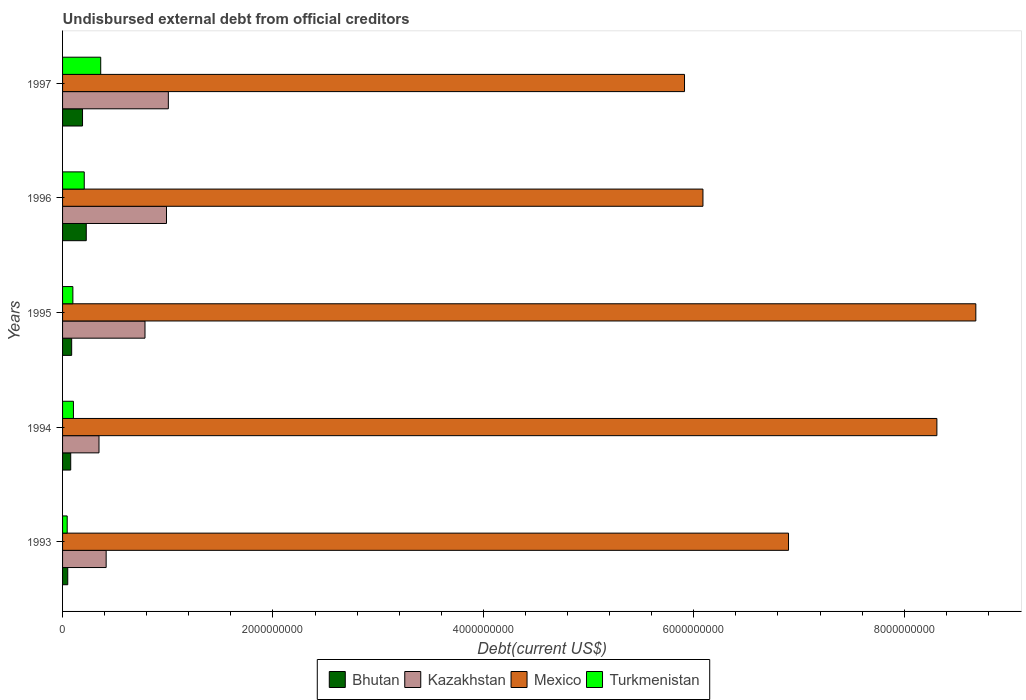Are the number of bars per tick equal to the number of legend labels?
Your response must be concise. Yes. Are the number of bars on each tick of the Y-axis equal?
Your response must be concise. Yes. How many bars are there on the 3rd tick from the top?
Make the answer very short. 4. How many bars are there on the 5th tick from the bottom?
Provide a short and direct response. 4. In how many cases, is the number of bars for a given year not equal to the number of legend labels?
Offer a very short reply. 0. What is the total debt in Bhutan in 1997?
Make the answer very short. 1.90e+08. Across all years, what is the maximum total debt in Mexico?
Offer a very short reply. 8.68e+09. Across all years, what is the minimum total debt in Bhutan?
Your answer should be compact. 4.93e+07. In which year was the total debt in Mexico maximum?
Your answer should be very brief. 1995. What is the total total debt in Kazakhstan in the graph?
Make the answer very short. 3.54e+09. What is the difference between the total debt in Mexico in 1994 and that in 1997?
Your answer should be very brief. 2.40e+09. What is the difference between the total debt in Kazakhstan in 1994 and the total debt in Turkmenistan in 1996?
Your answer should be very brief. 1.40e+08. What is the average total debt in Bhutan per year?
Give a very brief answer. 1.26e+08. In the year 1996, what is the difference between the total debt in Bhutan and total debt in Mexico?
Your response must be concise. -5.86e+09. What is the ratio of the total debt in Turkmenistan in 1993 to that in 1995?
Your response must be concise. 0.45. What is the difference between the highest and the second highest total debt in Turkmenistan?
Your answer should be very brief. 1.57e+08. What is the difference between the highest and the lowest total debt in Mexico?
Keep it short and to the point. 2.77e+09. In how many years, is the total debt in Bhutan greater than the average total debt in Bhutan taken over all years?
Provide a succinct answer. 2. Is the sum of the total debt in Bhutan in 1995 and 1997 greater than the maximum total debt in Mexico across all years?
Ensure brevity in your answer.  No. Is it the case that in every year, the sum of the total debt in Mexico and total debt in Kazakhstan is greater than the sum of total debt in Turkmenistan and total debt in Bhutan?
Provide a short and direct response. No. What does the 1st bar from the bottom in 1993 represents?
Keep it short and to the point. Bhutan. Is it the case that in every year, the sum of the total debt in Mexico and total debt in Bhutan is greater than the total debt in Kazakhstan?
Provide a succinct answer. Yes. How many bars are there?
Offer a very short reply. 20. Are all the bars in the graph horizontal?
Make the answer very short. Yes. How many years are there in the graph?
Offer a terse response. 5. What is the difference between two consecutive major ticks on the X-axis?
Make the answer very short. 2.00e+09. Does the graph contain grids?
Make the answer very short. No. Where does the legend appear in the graph?
Provide a succinct answer. Bottom center. How many legend labels are there?
Provide a short and direct response. 4. How are the legend labels stacked?
Your answer should be very brief. Horizontal. What is the title of the graph?
Ensure brevity in your answer.  Undisbursed external debt from official creditors. Does "Somalia" appear as one of the legend labels in the graph?
Offer a very short reply. No. What is the label or title of the X-axis?
Keep it short and to the point. Debt(current US$). What is the Debt(current US$) in Bhutan in 1993?
Keep it short and to the point. 4.93e+07. What is the Debt(current US$) of Kazakhstan in 1993?
Provide a succinct answer. 4.14e+08. What is the Debt(current US$) of Mexico in 1993?
Offer a very short reply. 6.90e+09. What is the Debt(current US$) in Turkmenistan in 1993?
Keep it short and to the point. 4.41e+07. What is the Debt(current US$) of Bhutan in 1994?
Offer a very short reply. 7.74e+07. What is the Debt(current US$) of Kazakhstan in 1994?
Your answer should be very brief. 3.46e+08. What is the Debt(current US$) in Mexico in 1994?
Offer a very short reply. 8.31e+09. What is the Debt(current US$) of Turkmenistan in 1994?
Give a very brief answer. 1.03e+08. What is the Debt(current US$) in Bhutan in 1995?
Your response must be concise. 8.66e+07. What is the Debt(current US$) in Kazakhstan in 1995?
Your answer should be very brief. 7.84e+08. What is the Debt(current US$) of Mexico in 1995?
Provide a succinct answer. 8.68e+09. What is the Debt(current US$) of Turkmenistan in 1995?
Offer a very short reply. 9.80e+07. What is the Debt(current US$) of Bhutan in 1996?
Give a very brief answer. 2.25e+08. What is the Debt(current US$) of Kazakhstan in 1996?
Ensure brevity in your answer.  9.88e+08. What is the Debt(current US$) in Mexico in 1996?
Ensure brevity in your answer.  6.09e+09. What is the Debt(current US$) in Turkmenistan in 1996?
Make the answer very short. 2.06e+08. What is the Debt(current US$) in Bhutan in 1997?
Provide a short and direct response. 1.90e+08. What is the Debt(current US$) of Kazakhstan in 1997?
Give a very brief answer. 1.01e+09. What is the Debt(current US$) in Mexico in 1997?
Provide a succinct answer. 5.91e+09. What is the Debt(current US$) of Turkmenistan in 1997?
Offer a terse response. 3.63e+08. Across all years, what is the maximum Debt(current US$) of Bhutan?
Your response must be concise. 2.25e+08. Across all years, what is the maximum Debt(current US$) of Kazakhstan?
Offer a terse response. 1.01e+09. Across all years, what is the maximum Debt(current US$) in Mexico?
Give a very brief answer. 8.68e+09. Across all years, what is the maximum Debt(current US$) of Turkmenistan?
Offer a terse response. 3.63e+08. Across all years, what is the minimum Debt(current US$) in Bhutan?
Provide a succinct answer. 4.93e+07. Across all years, what is the minimum Debt(current US$) of Kazakhstan?
Keep it short and to the point. 3.46e+08. Across all years, what is the minimum Debt(current US$) in Mexico?
Your response must be concise. 5.91e+09. Across all years, what is the minimum Debt(current US$) in Turkmenistan?
Offer a very short reply. 4.41e+07. What is the total Debt(current US$) in Bhutan in the graph?
Your answer should be very brief. 6.28e+08. What is the total Debt(current US$) in Kazakhstan in the graph?
Ensure brevity in your answer.  3.54e+09. What is the total Debt(current US$) of Mexico in the graph?
Your answer should be very brief. 3.59e+1. What is the total Debt(current US$) of Turkmenistan in the graph?
Provide a succinct answer. 8.14e+08. What is the difference between the Debt(current US$) of Bhutan in 1993 and that in 1994?
Your response must be concise. -2.82e+07. What is the difference between the Debt(current US$) in Kazakhstan in 1993 and that in 1994?
Provide a succinct answer. 6.80e+07. What is the difference between the Debt(current US$) in Mexico in 1993 and that in 1994?
Make the answer very short. -1.41e+09. What is the difference between the Debt(current US$) of Turkmenistan in 1993 and that in 1994?
Make the answer very short. -5.92e+07. What is the difference between the Debt(current US$) of Bhutan in 1993 and that in 1995?
Offer a very short reply. -3.73e+07. What is the difference between the Debt(current US$) in Kazakhstan in 1993 and that in 1995?
Give a very brief answer. -3.69e+08. What is the difference between the Debt(current US$) in Mexico in 1993 and that in 1995?
Provide a short and direct response. -1.78e+09. What is the difference between the Debt(current US$) in Turkmenistan in 1993 and that in 1995?
Your answer should be very brief. -5.39e+07. What is the difference between the Debt(current US$) in Bhutan in 1993 and that in 1996?
Offer a terse response. -1.76e+08. What is the difference between the Debt(current US$) of Kazakhstan in 1993 and that in 1996?
Provide a succinct answer. -5.74e+08. What is the difference between the Debt(current US$) in Mexico in 1993 and that in 1996?
Your answer should be compact. 8.13e+08. What is the difference between the Debt(current US$) in Turkmenistan in 1993 and that in 1996?
Your response must be concise. -1.62e+08. What is the difference between the Debt(current US$) in Bhutan in 1993 and that in 1997?
Make the answer very short. -1.40e+08. What is the difference between the Debt(current US$) in Kazakhstan in 1993 and that in 1997?
Your response must be concise. -5.91e+08. What is the difference between the Debt(current US$) in Mexico in 1993 and that in 1997?
Offer a very short reply. 9.88e+08. What is the difference between the Debt(current US$) in Turkmenistan in 1993 and that in 1997?
Keep it short and to the point. -3.18e+08. What is the difference between the Debt(current US$) of Bhutan in 1994 and that in 1995?
Keep it short and to the point. -9.17e+06. What is the difference between the Debt(current US$) of Kazakhstan in 1994 and that in 1995?
Give a very brief answer. -4.37e+08. What is the difference between the Debt(current US$) in Mexico in 1994 and that in 1995?
Ensure brevity in your answer.  -3.70e+08. What is the difference between the Debt(current US$) of Turkmenistan in 1994 and that in 1995?
Provide a succinct answer. 5.30e+06. What is the difference between the Debt(current US$) in Bhutan in 1994 and that in 1996?
Your answer should be very brief. -1.48e+08. What is the difference between the Debt(current US$) in Kazakhstan in 1994 and that in 1996?
Ensure brevity in your answer.  -6.42e+08. What is the difference between the Debt(current US$) of Mexico in 1994 and that in 1996?
Give a very brief answer. 2.22e+09. What is the difference between the Debt(current US$) of Turkmenistan in 1994 and that in 1996?
Offer a terse response. -1.03e+08. What is the difference between the Debt(current US$) of Bhutan in 1994 and that in 1997?
Your answer should be very brief. -1.12e+08. What is the difference between the Debt(current US$) of Kazakhstan in 1994 and that in 1997?
Offer a very short reply. -6.59e+08. What is the difference between the Debt(current US$) of Mexico in 1994 and that in 1997?
Your response must be concise. 2.40e+09. What is the difference between the Debt(current US$) of Turkmenistan in 1994 and that in 1997?
Offer a terse response. -2.59e+08. What is the difference between the Debt(current US$) in Bhutan in 1995 and that in 1996?
Provide a short and direct response. -1.39e+08. What is the difference between the Debt(current US$) of Kazakhstan in 1995 and that in 1996?
Provide a short and direct response. -2.04e+08. What is the difference between the Debt(current US$) in Mexico in 1995 and that in 1996?
Your response must be concise. 2.59e+09. What is the difference between the Debt(current US$) of Turkmenistan in 1995 and that in 1996?
Make the answer very short. -1.08e+08. What is the difference between the Debt(current US$) of Bhutan in 1995 and that in 1997?
Your response must be concise. -1.03e+08. What is the difference between the Debt(current US$) in Kazakhstan in 1995 and that in 1997?
Offer a terse response. -2.22e+08. What is the difference between the Debt(current US$) of Mexico in 1995 and that in 1997?
Provide a succinct answer. 2.77e+09. What is the difference between the Debt(current US$) in Turkmenistan in 1995 and that in 1997?
Your response must be concise. -2.65e+08. What is the difference between the Debt(current US$) in Bhutan in 1996 and that in 1997?
Provide a succinct answer. 3.55e+07. What is the difference between the Debt(current US$) in Kazakhstan in 1996 and that in 1997?
Your response must be concise. -1.75e+07. What is the difference between the Debt(current US$) of Mexico in 1996 and that in 1997?
Offer a very short reply. 1.75e+08. What is the difference between the Debt(current US$) in Turkmenistan in 1996 and that in 1997?
Your answer should be very brief. -1.57e+08. What is the difference between the Debt(current US$) in Bhutan in 1993 and the Debt(current US$) in Kazakhstan in 1994?
Your response must be concise. -2.97e+08. What is the difference between the Debt(current US$) of Bhutan in 1993 and the Debt(current US$) of Mexico in 1994?
Make the answer very short. -8.26e+09. What is the difference between the Debt(current US$) in Bhutan in 1993 and the Debt(current US$) in Turkmenistan in 1994?
Give a very brief answer. -5.40e+07. What is the difference between the Debt(current US$) of Kazakhstan in 1993 and the Debt(current US$) of Mexico in 1994?
Make the answer very short. -7.90e+09. What is the difference between the Debt(current US$) of Kazakhstan in 1993 and the Debt(current US$) of Turkmenistan in 1994?
Keep it short and to the point. 3.11e+08. What is the difference between the Debt(current US$) of Mexico in 1993 and the Debt(current US$) of Turkmenistan in 1994?
Your answer should be very brief. 6.80e+09. What is the difference between the Debt(current US$) of Bhutan in 1993 and the Debt(current US$) of Kazakhstan in 1995?
Make the answer very short. -7.34e+08. What is the difference between the Debt(current US$) of Bhutan in 1993 and the Debt(current US$) of Mexico in 1995?
Make the answer very short. -8.63e+09. What is the difference between the Debt(current US$) in Bhutan in 1993 and the Debt(current US$) in Turkmenistan in 1995?
Make the answer very short. -4.87e+07. What is the difference between the Debt(current US$) in Kazakhstan in 1993 and the Debt(current US$) in Mexico in 1995?
Make the answer very short. -8.27e+09. What is the difference between the Debt(current US$) in Kazakhstan in 1993 and the Debt(current US$) in Turkmenistan in 1995?
Provide a short and direct response. 3.16e+08. What is the difference between the Debt(current US$) of Mexico in 1993 and the Debt(current US$) of Turkmenistan in 1995?
Offer a very short reply. 6.80e+09. What is the difference between the Debt(current US$) in Bhutan in 1993 and the Debt(current US$) in Kazakhstan in 1996?
Provide a short and direct response. -9.39e+08. What is the difference between the Debt(current US$) of Bhutan in 1993 and the Debt(current US$) of Mexico in 1996?
Ensure brevity in your answer.  -6.04e+09. What is the difference between the Debt(current US$) of Bhutan in 1993 and the Debt(current US$) of Turkmenistan in 1996?
Your answer should be very brief. -1.57e+08. What is the difference between the Debt(current US$) of Kazakhstan in 1993 and the Debt(current US$) of Mexico in 1996?
Offer a very short reply. -5.67e+09. What is the difference between the Debt(current US$) in Kazakhstan in 1993 and the Debt(current US$) in Turkmenistan in 1996?
Keep it short and to the point. 2.08e+08. What is the difference between the Debt(current US$) of Mexico in 1993 and the Debt(current US$) of Turkmenistan in 1996?
Provide a short and direct response. 6.69e+09. What is the difference between the Debt(current US$) in Bhutan in 1993 and the Debt(current US$) in Kazakhstan in 1997?
Your answer should be very brief. -9.56e+08. What is the difference between the Debt(current US$) of Bhutan in 1993 and the Debt(current US$) of Mexico in 1997?
Your response must be concise. -5.86e+09. What is the difference between the Debt(current US$) of Bhutan in 1993 and the Debt(current US$) of Turkmenistan in 1997?
Provide a succinct answer. -3.13e+08. What is the difference between the Debt(current US$) in Kazakhstan in 1993 and the Debt(current US$) in Mexico in 1997?
Provide a succinct answer. -5.50e+09. What is the difference between the Debt(current US$) of Kazakhstan in 1993 and the Debt(current US$) of Turkmenistan in 1997?
Your response must be concise. 5.17e+07. What is the difference between the Debt(current US$) in Mexico in 1993 and the Debt(current US$) in Turkmenistan in 1997?
Ensure brevity in your answer.  6.54e+09. What is the difference between the Debt(current US$) of Bhutan in 1994 and the Debt(current US$) of Kazakhstan in 1995?
Your response must be concise. -7.06e+08. What is the difference between the Debt(current US$) of Bhutan in 1994 and the Debt(current US$) of Mexico in 1995?
Offer a terse response. -8.60e+09. What is the difference between the Debt(current US$) in Bhutan in 1994 and the Debt(current US$) in Turkmenistan in 1995?
Your answer should be compact. -2.06e+07. What is the difference between the Debt(current US$) in Kazakhstan in 1994 and the Debt(current US$) in Mexico in 1995?
Make the answer very short. -8.33e+09. What is the difference between the Debt(current US$) of Kazakhstan in 1994 and the Debt(current US$) of Turkmenistan in 1995?
Your response must be concise. 2.48e+08. What is the difference between the Debt(current US$) of Mexico in 1994 and the Debt(current US$) of Turkmenistan in 1995?
Provide a succinct answer. 8.21e+09. What is the difference between the Debt(current US$) in Bhutan in 1994 and the Debt(current US$) in Kazakhstan in 1996?
Your answer should be compact. -9.10e+08. What is the difference between the Debt(current US$) in Bhutan in 1994 and the Debt(current US$) in Mexico in 1996?
Give a very brief answer. -6.01e+09. What is the difference between the Debt(current US$) of Bhutan in 1994 and the Debt(current US$) of Turkmenistan in 1996?
Ensure brevity in your answer.  -1.29e+08. What is the difference between the Debt(current US$) in Kazakhstan in 1994 and the Debt(current US$) in Mexico in 1996?
Your answer should be compact. -5.74e+09. What is the difference between the Debt(current US$) of Kazakhstan in 1994 and the Debt(current US$) of Turkmenistan in 1996?
Your answer should be compact. 1.40e+08. What is the difference between the Debt(current US$) of Mexico in 1994 and the Debt(current US$) of Turkmenistan in 1996?
Provide a succinct answer. 8.10e+09. What is the difference between the Debt(current US$) in Bhutan in 1994 and the Debt(current US$) in Kazakhstan in 1997?
Give a very brief answer. -9.28e+08. What is the difference between the Debt(current US$) of Bhutan in 1994 and the Debt(current US$) of Mexico in 1997?
Provide a succinct answer. -5.83e+09. What is the difference between the Debt(current US$) in Bhutan in 1994 and the Debt(current US$) in Turkmenistan in 1997?
Your answer should be compact. -2.85e+08. What is the difference between the Debt(current US$) in Kazakhstan in 1994 and the Debt(current US$) in Mexico in 1997?
Make the answer very short. -5.57e+09. What is the difference between the Debt(current US$) in Kazakhstan in 1994 and the Debt(current US$) in Turkmenistan in 1997?
Provide a short and direct response. -1.63e+07. What is the difference between the Debt(current US$) in Mexico in 1994 and the Debt(current US$) in Turkmenistan in 1997?
Your answer should be very brief. 7.95e+09. What is the difference between the Debt(current US$) of Bhutan in 1995 and the Debt(current US$) of Kazakhstan in 1996?
Provide a short and direct response. -9.01e+08. What is the difference between the Debt(current US$) of Bhutan in 1995 and the Debt(current US$) of Mexico in 1996?
Your response must be concise. -6.00e+09. What is the difference between the Debt(current US$) of Bhutan in 1995 and the Debt(current US$) of Turkmenistan in 1996?
Your answer should be compact. -1.19e+08. What is the difference between the Debt(current US$) in Kazakhstan in 1995 and the Debt(current US$) in Mexico in 1996?
Your response must be concise. -5.30e+09. What is the difference between the Debt(current US$) of Kazakhstan in 1995 and the Debt(current US$) of Turkmenistan in 1996?
Your response must be concise. 5.78e+08. What is the difference between the Debt(current US$) in Mexico in 1995 and the Debt(current US$) in Turkmenistan in 1996?
Provide a short and direct response. 8.47e+09. What is the difference between the Debt(current US$) in Bhutan in 1995 and the Debt(current US$) in Kazakhstan in 1997?
Your answer should be very brief. -9.19e+08. What is the difference between the Debt(current US$) of Bhutan in 1995 and the Debt(current US$) of Mexico in 1997?
Your answer should be very brief. -5.83e+09. What is the difference between the Debt(current US$) of Bhutan in 1995 and the Debt(current US$) of Turkmenistan in 1997?
Give a very brief answer. -2.76e+08. What is the difference between the Debt(current US$) in Kazakhstan in 1995 and the Debt(current US$) in Mexico in 1997?
Offer a very short reply. -5.13e+09. What is the difference between the Debt(current US$) in Kazakhstan in 1995 and the Debt(current US$) in Turkmenistan in 1997?
Provide a succinct answer. 4.21e+08. What is the difference between the Debt(current US$) of Mexico in 1995 and the Debt(current US$) of Turkmenistan in 1997?
Offer a very short reply. 8.32e+09. What is the difference between the Debt(current US$) in Bhutan in 1996 and the Debt(current US$) in Kazakhstan in 1997?
Provide a succinct answer. -7.80e+08. What is the difference between the Debt(current US$) in Bhutan in 1996 and the Debt(current US$) in Mexico in 1997?
Your answer should be compact. -5.69e+09. What is the difference between the Debt(current US$) of Bhutan in 1996 and the Debt(current US$) of Turkmenistan in 1997?
Provide a succinct answer. -1.37e+08. What is the difference between the Debt(current US$) in Kazakhstan in 1996 and the Debt(current US$) in Mexico in 1997?
Keep it short and to the point. -4.92e+09. What is the difference between the Debt(current US$) in Kazakhstan in 1996 and the Debt(current US$) in Turkmenistan in 1997?
Offer a very short reply. 6.25e+08. What is the difference between the Debt(current US$) of Mexico in 1996 and the Debt(current US$) of Turkmenistan in 1997?
Your answer should be compact. 5.72e+09. What is the average Debt(current US$) of Bhutan per year?
Make the answer very short. 1.26e+08. What is the average Debt(current US$) in Kazakhstan per year?
Provide a succinct answer. 7.08e+08. What is the average Debt(current US$) in Mexico per year?
Provide a short and direct response. 7.18e+09. What is the average Debt(current US$) in Turkmenistan per year?
Your response must be concise. 1.63e+08. In the year 1993, what is the difference between the Debt(current US$) of Bhutan and Debt(current US$) of Kazakhstan?
Your answer should be compact. -3.65e+08. In the year 1993, what is the difference between the Debt(current US$) in Bhutan and Debt(current US$) in Mexico?
Make the answer very short. -6.85e+09. In the year 1993, what is the difference between the Debt(current US$) of Bhutan and Debt(current US$) of Turkmenistan?
Offer a terse response. 5.14e+06. In the year 1993, what is the difference between the Debt(current US$) in Kazakhstan and Debt(current US$) in Mexico?
Your answer should be compact. -6.49e+09. In the year 1993, what is the difference between the Debt(current US$) of Kazakhstan and Debt(current US$) of Turkmenistan?
Give a very brief answer. 3.70e+08. In the year 1993, what is the difference between the Debt(current US$) in Mexico and Debt(current US$) in Turkmenistan?
Your response must be concise. 6.86e+09. In the year 1994, what is the difference between the Debt(current US$) of Bhutan and Debt(current US$) of Kazakhstan?
Ensure brevity in your answer.  -2.69e+08. In the year 1994, what is the difference between the Debt(current US$) in Bhutan and Debt(current US$) in Mexico?
Ensure brevity in your answer.  -8.23e+09. In the year 1994, what is the difference between the Debt(current US$) of Bhutan and Debt(current US$) of Turkmenistan?
Your answer should be compact. -2.59e+07. In the year 1994, what is the difference between the Debt(current US$) in Kazakhstan and Debt(current US$) in Mexico?
Ensure brevity in your answer.  -7.96e+09. In the year 1994, what is the difference between the Debt(current US$) in Kazakhstan and Debt(current US$) in Turkmenistan?
Give a very brief answer. 2.43e+08. In the year 1994, what is the difference between the Debt(current US$) in Mexico and Debt(current US$) in Turkmenistan?
Provide a succinct answer. 8.21e+09. In the year 1995, what is the difference between the Debt(current US$) in Bhutan and Debt(current US$) in Kazakhstan?
Keep it short and to the point. -6.97e+08. In the year 1995, what is the difference between the Debt(current US$) in Bhutan and Debt(current US$) in Mexico?
Offer a very short reply. -8.59e+09. In the year 1995, what is the difference between the Debt(current US$) of Bhutan and Debt(current US$) of Turkmenistan?
Keep it short and to the point. -1.14e+07. In the year 1995, what is the difference between the Debt(current US$) of Kazakhstan and Debt(current US$) of Mexico?
Your answer should be very brief. -7.90e+09. In the year 1995, what is the difference between the Debt(current US$) of Kazakhstan and Debt(current US$) of Turkmenistan?
Keep it short and to the point. 6.86e+08. In the year 1995, what is the difference between the Debt(current US$) of Mexico and Debt(current US$) of Turkmenistan?
Make the answer very short. 8.58e+09. In the year 1996, what is the difference between the Debt(current US$) of Bhutan and Debt(current US$) of Kazakhstan?
Ensure brevity in your answer.  -7.63e+08. In the year 1996, what is the difference between the Debt(current US$) in Bhutan and Debt(current US$) in Mexico?
Keep it short and to the point. -5.86e+09. In the year 1996, what is the difference between the Debt(current US$) in Bhutan and Debt(current US$) in Turkmenistan?
Provide a short and direct response. 1.92e+07. In the year 1996, what is the difference between the Debt(current US$) of Kazakhstan and Debt(current US$) of Mexico?
Provide a short and direct response. -5.10e+09. In the year 1996, what is the difference between the Debt(current US$) in Kazakhstan and Debt(current US$) in Turkmenistan?
Keep it short and to the point. 7.82e+08. In the year 1996, what is the difference between the Debt(current US$) of Mexico and Debt(current US$) of Turkmenistan?
Your answer should be compact. 5.88e+09. In the year 1997, what is the difference between the Debt(current US$) of Bhutan and Debt(current US$) of Kazakhstan?
Provide a succinct answer. -8.16e+08. In the year 1997, what is the difference between the Debt(current US$) in Bhutan and Debt(current US$) in Mexico?
Provide a succinct answer. -5.72e+09. In the year 1997, what is the difference between the Debt(current US$) of Bhutan and Debt(current US$) of Turkmenistan?
Your answer should be very brief. -1.73e+08. In the year 1997, what is the difference between the Debt(current US$) in Kazakhstan and Debt(current US$) in Mexico?
Your answer should be compact. -4.91e+09. In the year 1997, what is the difference between the Debt(current US$) in Kazakhstan and Debt(current US$) in Turkmenistan?
Make the answer very short. 6.43e+08. In the year 1997, what is the difference between the Debt(current US$) in Mexico and Debt(current US$) in Turkmenistan?
Provide a short and direct response. 5.55e+09. What is the ratio of the Debt(current US$) in Bhutan in 1993 to that in 1994?
Ensure brevity in your answer.  0.64. What is the ratio of the Debt(current US$) in Kazakhstan in 1993 to that in 1994?
Provide a succinct answer. 1.2. What is the ratio of the Debt(current US$) in Mexico in 1993 to that in 1994?
Provide a short and direct response. 0.83. What is the ratio of the Debt(current US$) of Turkmenistan in 1993 to that in 1994?
Your answer should be very brief. 0.43. What is the ratio of the Debt(current US$) of Bhutan in 1993 to that in 1995?
Provide a succinct answer. 0.57. What is the ratio of the Debt(current US$) in Kazakhstan in 1993 to that in 1995?
Your answer should be compact. 0.53. What is the ratio of the Debt(current US$) of Mexico in 1993 to that in 1995?
Provide a succinct answer. 0.79. What is the ratio of the Debt(current US$) of Turkmenistan in 1993 to that in 1995?
Your response must be concise. 0.45. What is the ratio of the Debt(current US$) in Bhutan in 1993 to that in 1996?
Provide a succinct answer. 0.22. What is the ratio of the Debt(current US$) of Kazakhstan in 1993 to that in 1996?
Provide a short and direct response. 0.42. What is the ratio of the Debt(current US$) of Mexico in 1993 to that in 1996?
Your response must be concise. 1.13. What is the ratio of the Debt(current US$) in Turkmenistan in 1993 to that in 1996?
Keep it short and to the point. 0.21. What is the ratio of the Debt(current US$) in Bhutan in 1993 to that in 1997?
Your response must be concise. 0.26. What is the ratio of the Debt(current US$) in Kazakhstan in 1993 to that in 1997?
Provide a short and direct response. 0.41. What is the ratio of the Debt(current US$) in Mexico in 1993 to that in 1997?
Your response must be concise. 1.17. What is the ratio of the Debt(current US$) in Turkmenistan in 1993 to that in 1997?
Ensure brevity in your answer.  0.12. What is the ratio of the Debt(current US$) of Bhutan in 1994 to that in 1995?
Ensure brevity in your answer.  0.89. What is the ratio of the Debt(current US$) in Kazakhstan in 1994 to that in 1995?
Offer a terse response. 0.44. What is the ratio of the Debt(current US$) in Mexico in 1994 to that in 1995?
Give a very brief answer. 0.96. What is the ratio of the Debt(current US$) in Turkmenistan in 1994 to that in 1995?
Your answer should be compact. 1.05. What is the ratio of the Debt(current US$) of Bhutan in 1994 to that in 1996?
Make the answer very short. 0.34. What is the ratio of the Debt(current US$) of Kazakhstan in 1994 to that in 1996?
Your answer should be compact. 0.35. What is the ratio of the Debt(current US$) in Mexico in 1994 to that in 1996?
Offer a very short reply. 1.37. What is the ratio of the Debt(current US$) of Turkmenistan in 1994 to that in 1996?
Provide a short and direct response. 0.5. What is the ratio of the Debt(current US$) in Bhutan in 1994 to that in 1997?
Make the answer very short. 0.41. What is the ratio of the Debt(current US$) in Kazakhstan in 1994 to that in 1997?
Make the answer very short. 0.34. What is the ratio of the Debt(current US$) of Mexico in 1994 to that in 1997?
Your answer should be very brief. 1.41. What is the ratio of the Debt(current US$) in Turkmenistan in 1994 to that in 1997?
Provide a succinct answer. 0.28. What is the ratio of the Debt(current US$) in Bhutan in 1995 to that in 1996?
Make the answer very short. 0.38. What is the ratio of the Debt(current US$) of Kazakhstan in 1995 to that in 1996?
Ensure brevity in your answer.  0.79. What is the ratio of the Debt(current US$) in Mexico in 1995 to that in 1996?
Your answer should be very brief. 1.43. What is the ratio of the Debt(current US$) in Turkmenistan in 1995 to that in 1996?
Offer a terse response. 0.48. What is the ratio of the Debt(current US$) of Bhutan in 1995 to that in 1997?
Provide a short and direct response. 0.46. What is the ratio of the Debt(current US$) of Kazakhstan in 1995 to that in 1997?
Ensure brevity in your answer.  0.78. What is the ratio of the Debt(current US$) of Mexico in 1995 to that in 1997?
Offer a terse response. 1.47. What is the ratio of the Debt(current US$) in Turkmenistan in 1995 to that in 1997?
Make the answer very short. 0.27. What is the ratio of the Debt(current US$) in Bhutan in 1996 to that in 1997?
Provide a short and direct response. 1.19. What is the ratio of the Debt(current US$) of Kazakhstan in 1996 to that in 1997?
Your answer should be compact. 0.98. What is the ratio of the Debt(current US$) in Mexico in 1996 to that in 1997?
Your answer should be compact. 1.03. What is the ratio of the Debt(current US$) of Turkmenistan in 1996 to that in 1997?
Your answer should be very brief. 0.57. What is the difference between the highest and the second highest Debt(current US$) in Bhutan?
Provide a succinct answer. 3.55e+07. What is the difference between the highest and the second highest Debt(current US$) of Kazakhstan?
Your answer should be compact. 1.75e+07. What is the difference between the highest and the second highest Debt(current US$) in Mexico?
Your answer should be compact. 3.70e+08. What is the difference between the highest and the second highest Debt(current US$) of Turkmenistan?
Make the answer very short. 1.57e+08. What is the difference between the highest and the lowest Debt(current US$) of Bhutan?
Your response must be concise. 1.76e+08. What is the difference between the highest and the lowest Debt(current US$) of Kazakhstan?
Give a very brief answer. 6.59e+08. What is the difference between the highest and the lowest Debt(current US$) in Mexico?
Keep it short and to the point. 2.77e+09. What is the difference between the highest and the lowest Debt(current US$) in Turkmenistan?
Your response must be concise. 3.18e+08. 